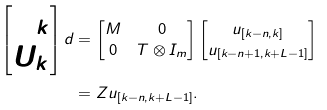<formula> <loc_0><loc_0><loc_500><loc_500>\begin{bmatrix} \Phi _ { k } \\ U _ { k } \end{bmatrix} d & = \begin{bmatrix} M & 0 \\ 0 & T \otimes I _ { m } \end{bmatrix} \begin{bmatrix} u _ { [ k - n , k ] } \\ u _ { [ k - n + 1 , k + L - 1 ] } \end{bmatrix} \\ & = Z u _ { [ k - n , k + L - 1 ] } .</formula> 